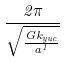<formula> <loc_0><loc_0><loc_500><loc_500>\frac { 2 \pi } { \sqrt { \frac { G k _ { y u c } } { a ^ { 1 } } } }</formula> 